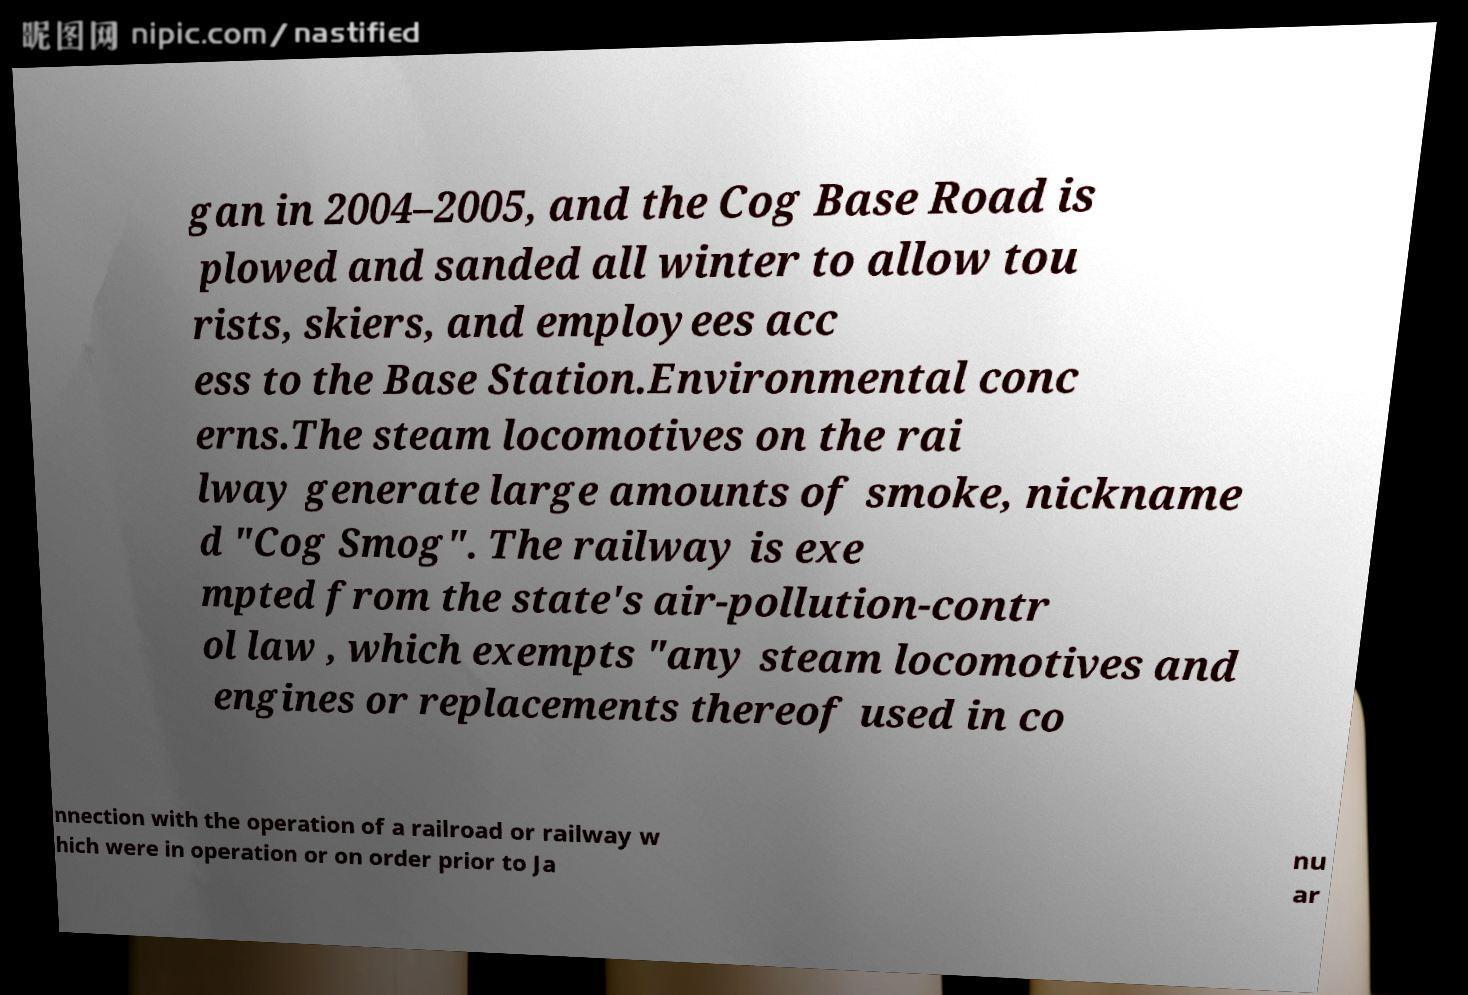Could you extract and type out the text from this image? gan in 2004–2005, and the Cog Base Road is plowed and sanded all winter to allow tou rists, skiers, and employees acc ess to the Base Station.Environmental conc erns.The steam locomotives on the rai lway generate large amounts of smoke, nickname d "Cog Smog". The railway is exe mpted from the state's air-pollution-contr ol law , which exempts "any steam locomotives and engines or replacements thereof used in co nnection with the operation of a railroad or railway w hich were in operation or on order prior to Ja nu ar 